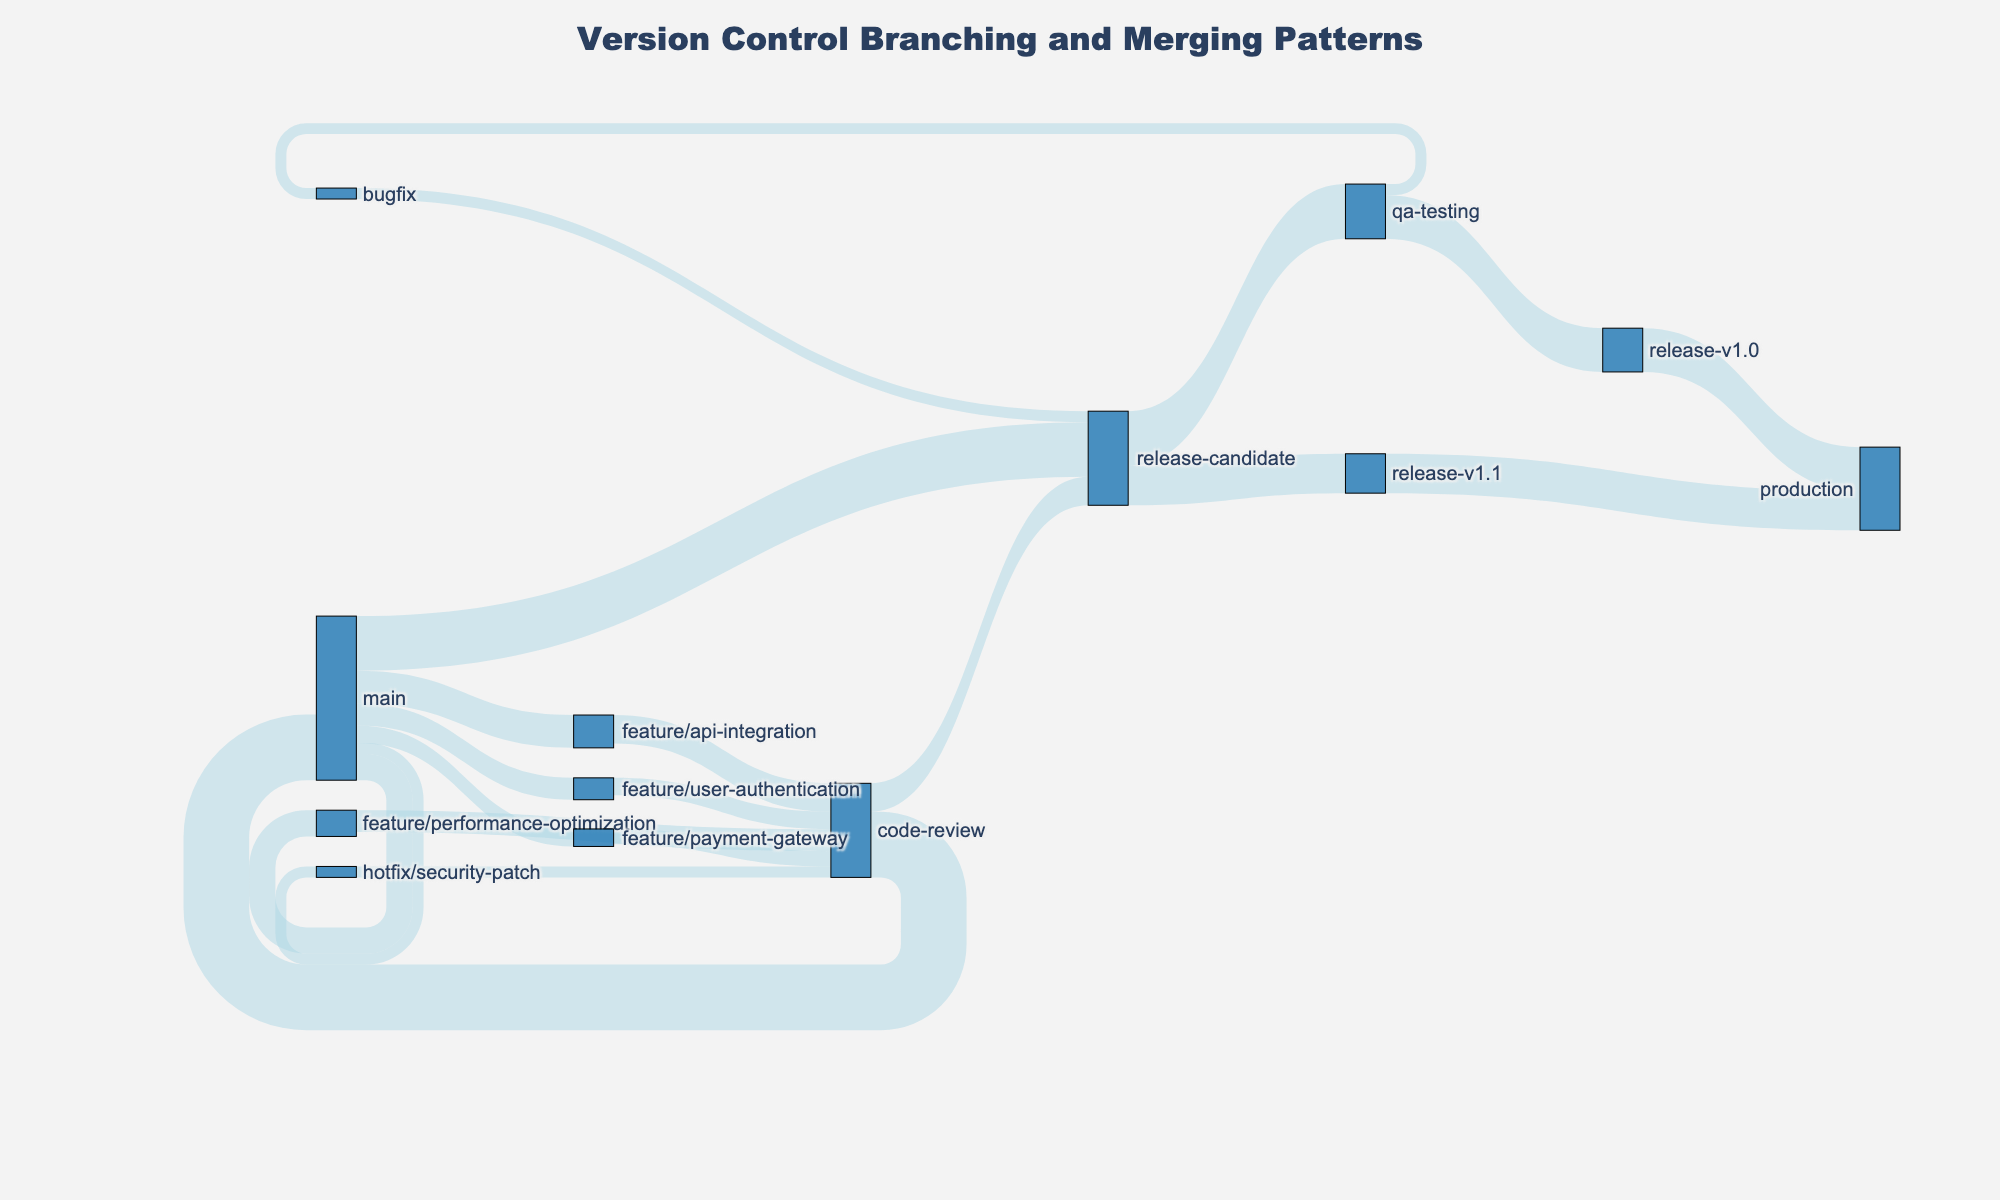what is the total number of nodes in the figure? Each source and target in the data represents a unique node. Combining all unique nodes from the source and target columns, we get: main, feature/user-authentication, feature/payment-gateway, feature/performance-optimization, hotfix/security-patch, code-review, release-candidate, qa-testing, bugfix, release-v1.0, production, feature/api-integration, release-v1.1. This results in 13 unique nodes.
Answer: 13 which branch has the largest value merging into the main branch? Examine the data values merging into the main branch node. The values are: feature/user-authentication (10), feature/payment-gateway (8), feature/performance-optimization (12), hotfix/security-patch (5), code-review (30), feature/api-integration (15). The largest value among these is from code-review, which is 30.
Answer: code-review what is the smallest value flowing into code-review? The source nodes flowing into code-review are feature/user-authentication (8), feature/payment-gateway (7), feature/performance-optimization (10), hotfix/security-patch (5), feature/api-integration (13). The smallest value among these is from hotfix/security-patch, which is 5.
Answer: 5 what percentage of the total value does the 'qa-testing' node evaluate? Calculate the total value flowing into the 'qa-testing' node. The value is from release-candidate (25). The total value in the dataset is the sum of all values (5+30+30+10+8+12+8+7+10+5+25+25+5+20+20+15+13+13+13+18). The total value sum is 233. The percentage of 'qa-testing' is (25/233) * 100 = 10.73%.
Answer: 10.73% which two nodes in the figure directly contribute to production? Look at the data values where the target node is production. The contributing nodes are release-v1.0 (20) and release-v1.1 (18).
Answer: release-v1.0, release-v1.1 which node has the most unique branches merging into it? Count the unique source nodes that contribute to each target node. The node with the most unique branches merging into it is code-review, with branches from feature/user-authentication, feature/payment-gateway, feature/performance-optimization, hotfix/security-patch, and feature/api-integration (total of 5 unique sources).
Answer: code-review compare the total values of feature branches and hotfix branches flowing into the code-review node. The feature branches flowing into code-review are feature/user-authentication (8), feature/payment-gateway (7), feature/performance-optimization (10), and feature/api-integration (13) totaling 38. The hotfix flow into code-review is hotfix/security-patch with a value of 5. The feature branches contribute significantly more.
Answer: Feature: 38, Hotfix: 5 what stage follows after the release-candidate node, leading up to production? Follow the path from the release-candidate node. The release-candidate node leads to qa-testing, which further branches into bugfix and release-v1.0. Release-v1.0 then leads to production. Additionally, release-candidate also leads directly to release-v1.1, which also results in production.
Answer: release-v1.0, release-v1.1 